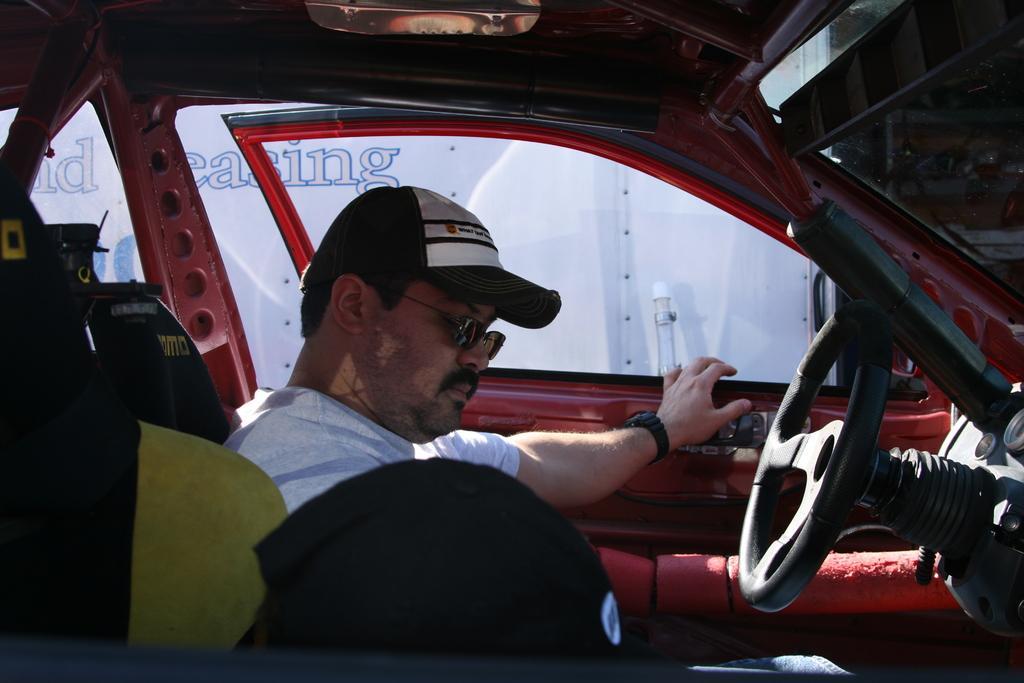In one or two sentences, can you explain what this image depicts? The picture is taken inside a car where the person is wearing a cap and t-shirt, in front of him there is a steering and behind him there are a caps and outside of the car there is a one white colour and some text on it. 